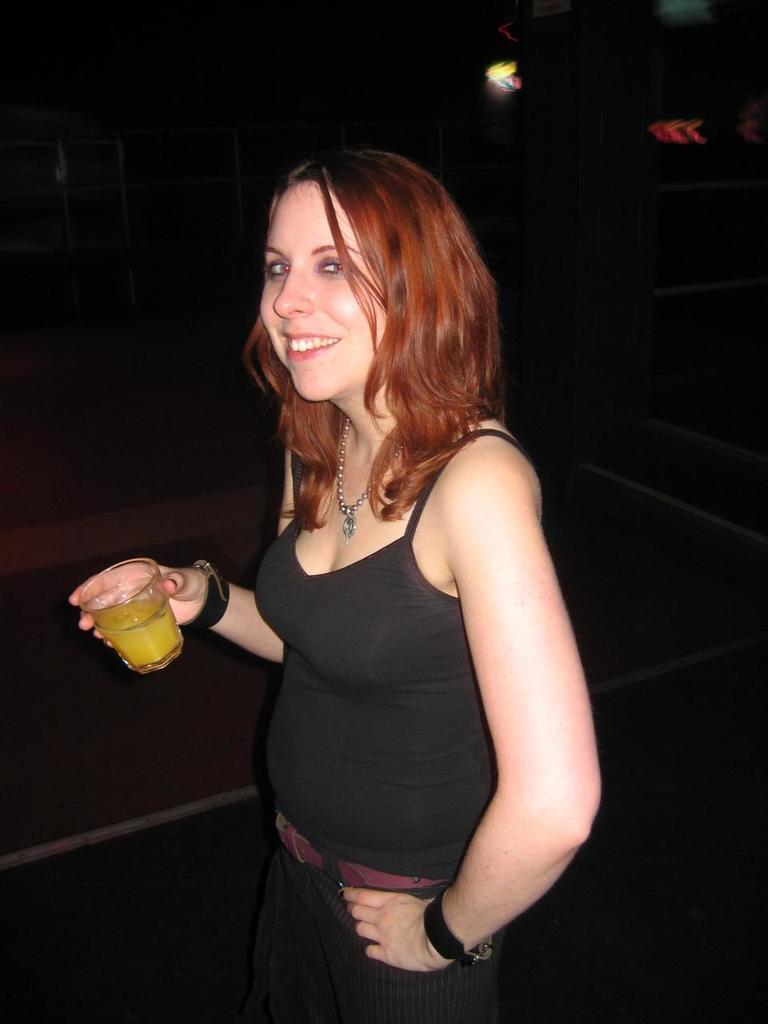Who is the main subject in the image? There is a woman in the image. What is the woman wearing? The woman is wearing a black dress. What is the woman doing in the image? The woman is standing and holding a glass in her hand. What can be seen in the background of the image? The background of the image is black. What type of beef is the woman holding in the image? The woman is not holding any beef in the image. 